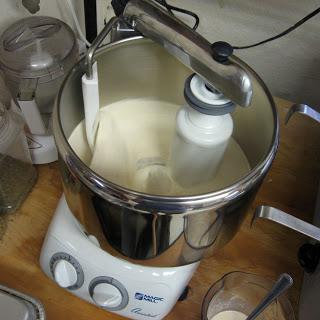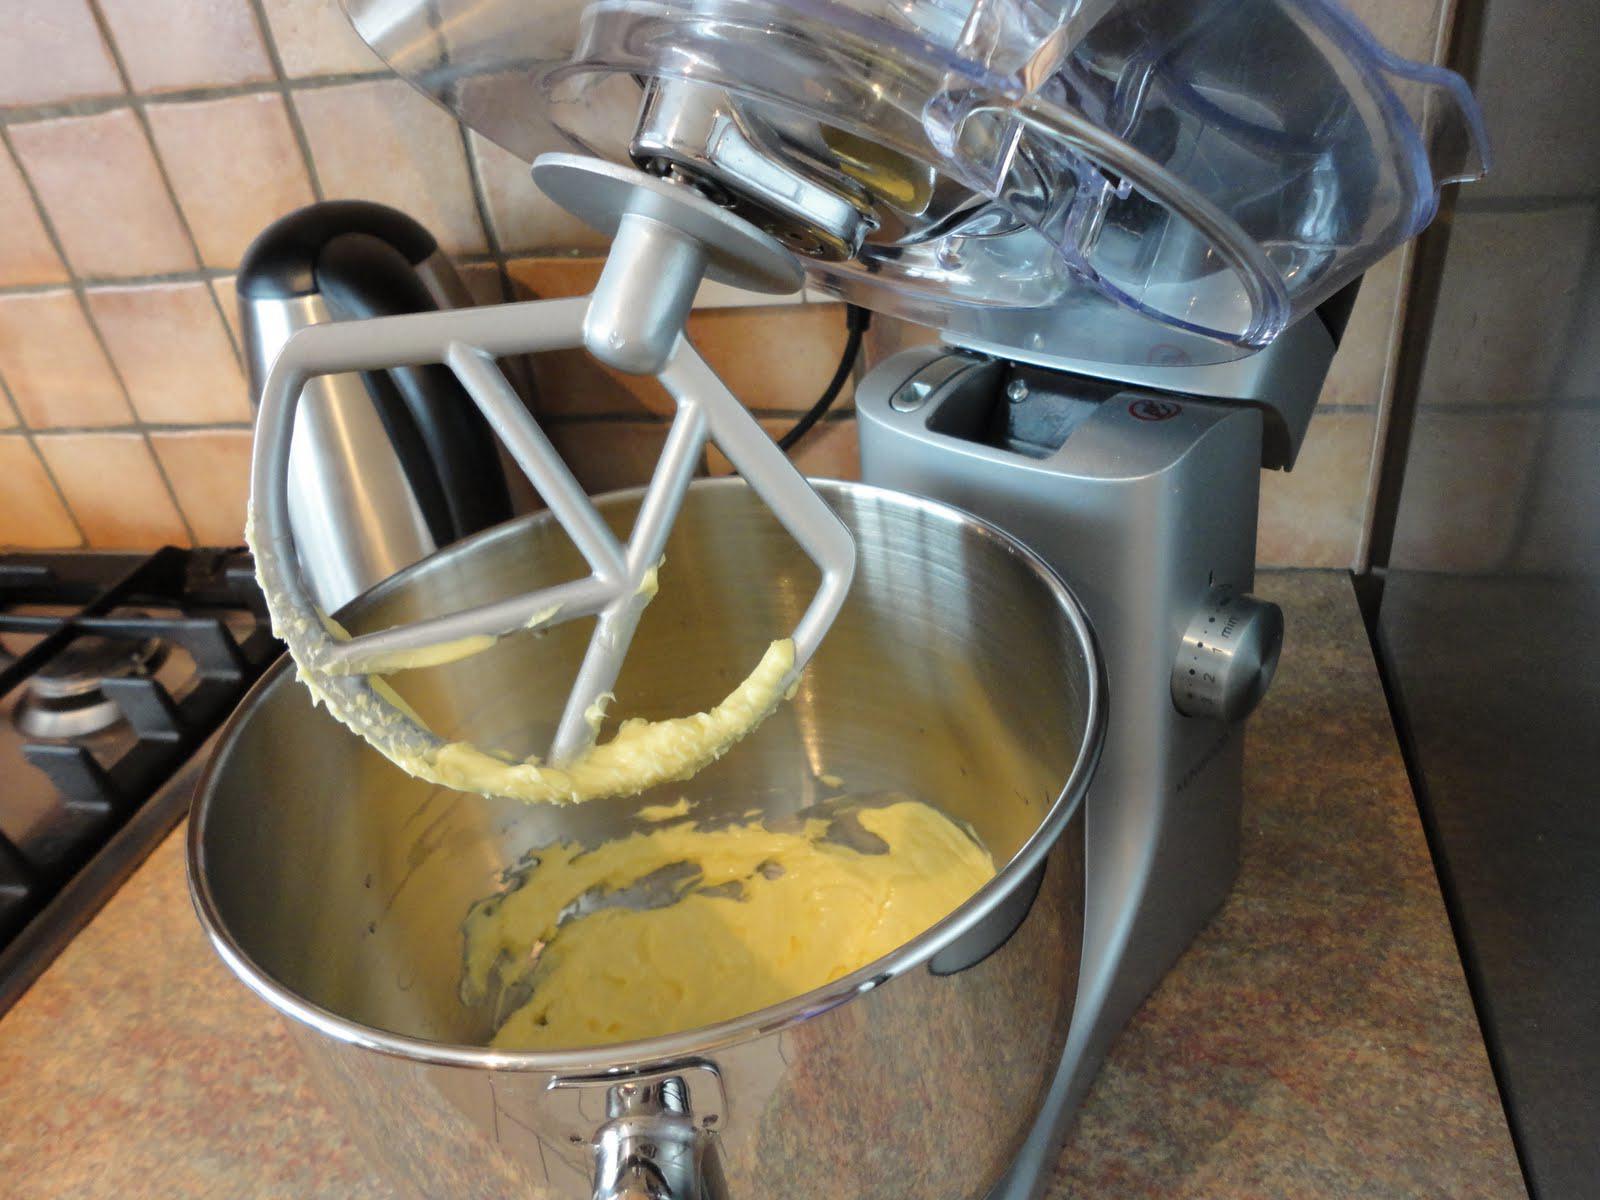The first image is the image on the left, the second image is the image on the right. For the images displayed, is the sentence "IN at least one image there is a black and silver kitchenaid  kneading dough." factually correct? Answer yes or no. No. The first image is the image on the left, the second image is the image on the right. For the images displayed, is the sentence "Each image shows a beater in a bowl of dough, but one image features a solid disk-shaped white beater blade and the other features a bar-shaped white blade." factually correct? Answer yes or no. No. 